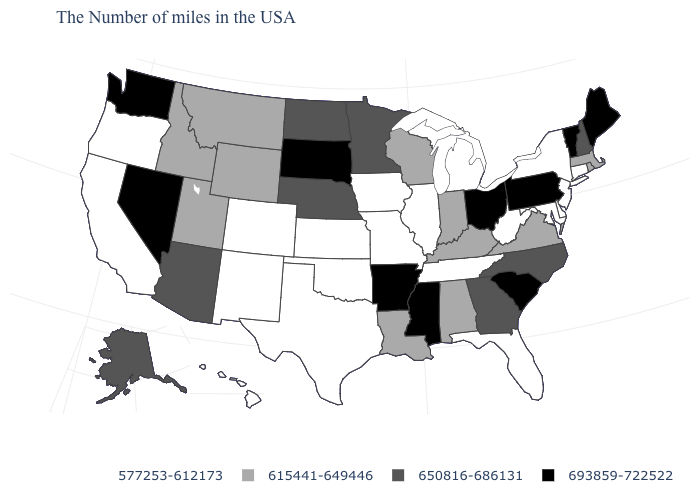What is the value of California?
Answer briefly. 577253-612173. What is the value of Connecticut?
Concise answer only. 577253-612173. What is the value of Nevada?
Write a very short answer. 693859-722522. Which states have the lowest value in the USA?
Give a very brief answer. Connecticut, New York, New Jersey, Delaware, Maryland, West Virginia, Florida, Michigan, Tennessee, Illinois, Missouri, Iowa, Kansas, Oklahoma, Texas, Colorado, New Mexico, California, Oregon, Hawaii. What is the highest value in the USA?
Write a very short answer. 693859-722522. Which states have the lowest value in the USA?
Be succinct. Connecticut, New York, New Jersey, Delaware, Maryland, West Virginia, Florida, Michigan, Tennessee, Illinois, Missouri, Iowa, Kansas, Oklahoma, Texas, Colorado, New Mexico, California, Oregon, Hawaii. Name the states that have a value in the range 577253-612173?
Be succinct. Connecticut, New York, New Jersey, Delaware, Maryland, West Virginia, Florida, Michigan, Tennessee, Illinois, Missouri, Iowa, Kansas, Oklahoma, Texas, Colorado, New Mexico, California, Oregon, Hawaii. Does Vermont have the highest value in the Northeast?
Concise answer only. Yes. What is the value of Wyoming?
Be succinct. 615441-649446. Does the first symbol in the legend represent the smallest category?
Concise answer only. Yes. Does Georgia have the highest value in the USA?
Answer briefly. No. Does Virginia have a lower value than Alabama?
Write a very short answer. No. Does North Dakota have a higher value than Texas?
Give a very brief answer. Yes. Is the legend a continuous bar?
Short answer required. No. Name the states that have a value in the range 615441-649446?
Write a very short answer. Massachusetts, Rhode Island, Virginia, Kentucky, Indiana, Alabama, Wisconsin, Louisiana, Wyoming, Utah, Montana, Idaho. 